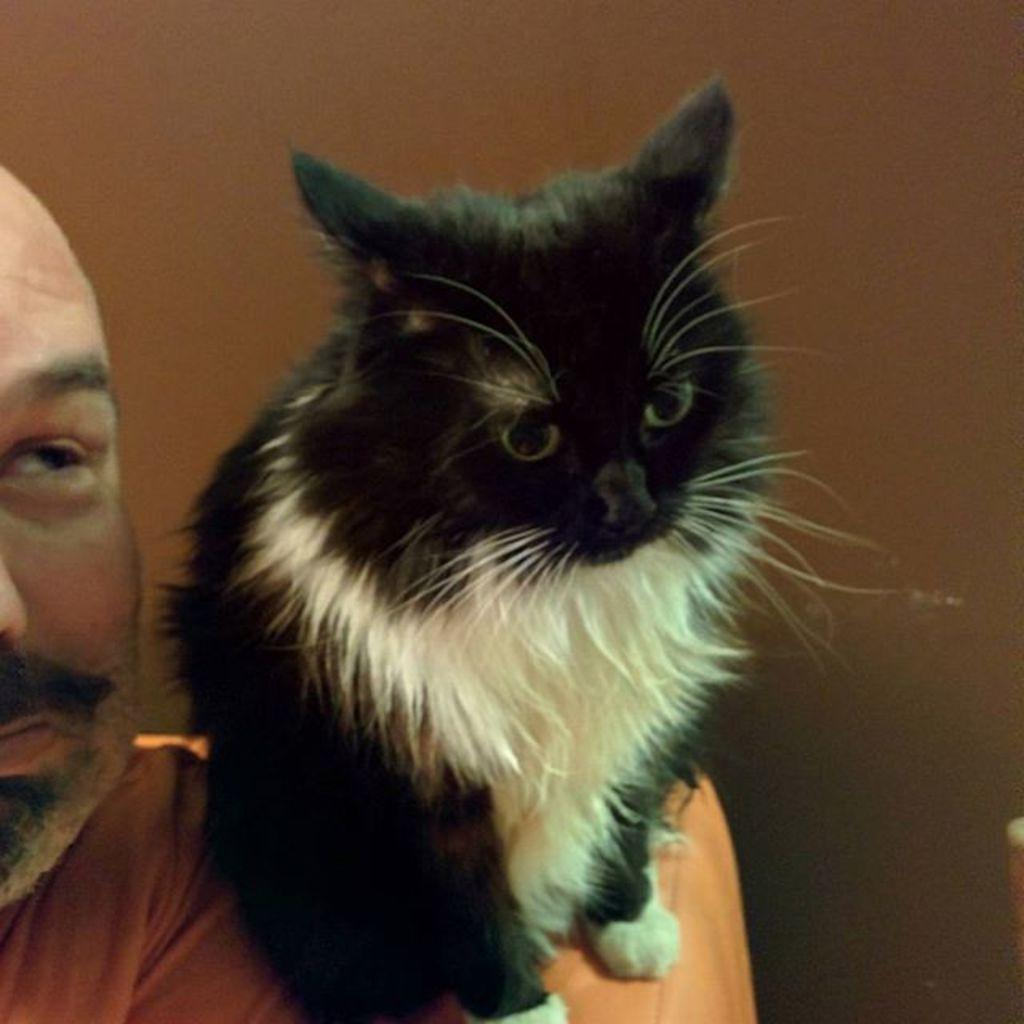Who or what is the main subject in the image? There is a person in the image. What is the person holding or interacting with in the image? The person has a black and white cat on their shoulder. What can be seen in the background of the image? There is a wall in the background of the image. What type of quiver is the person using to store seeds in the image? There is no quiver or seeds present in the image; it features a person with a cat on their shoulder and a wall in the background. 